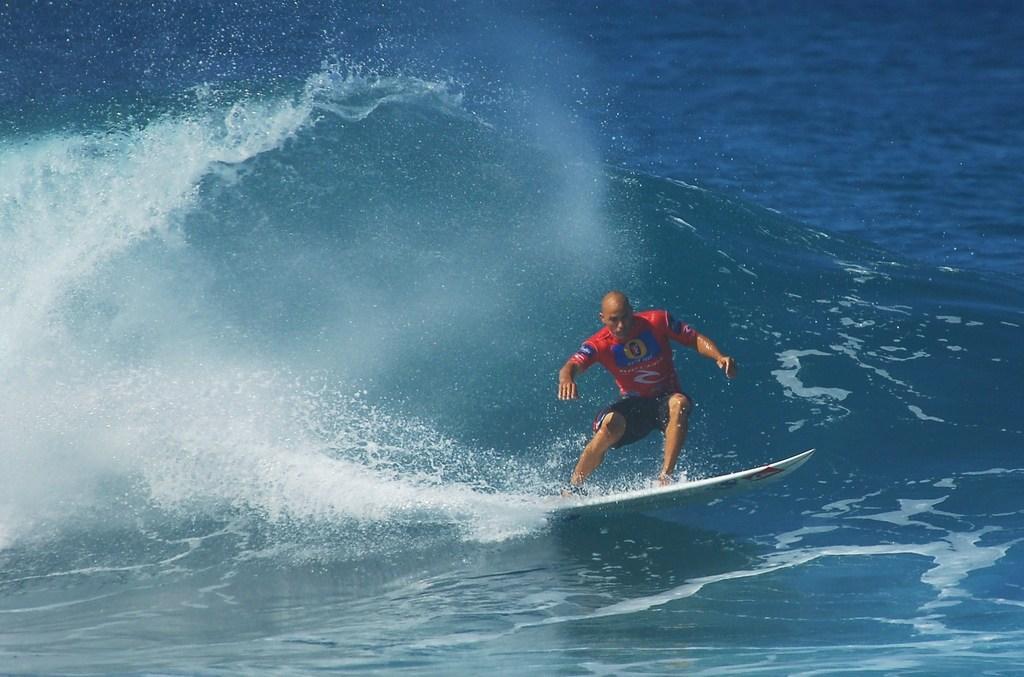Can you describe this image briefly? In this image I can see there is a water. And in water the person moving on a surfboard. 